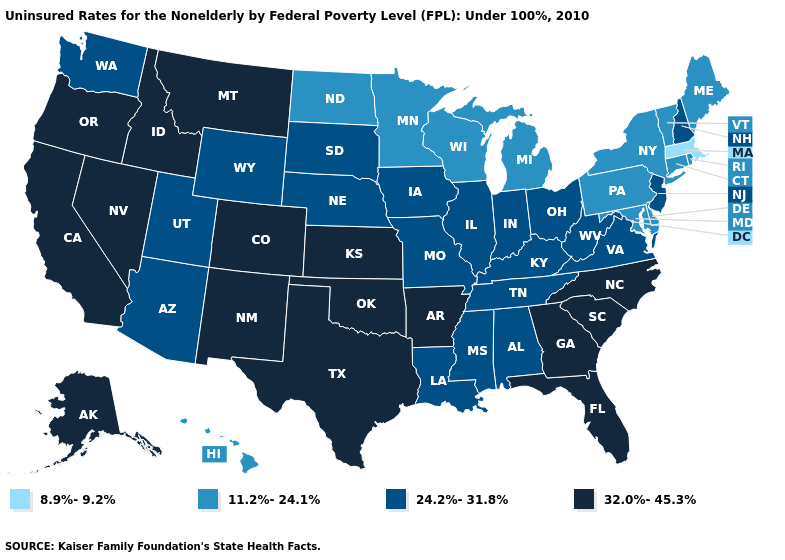What is the highest value in states that border New Hampshire?
Be succinct. 11.2%-24.1%. What is the lowest value in states that border Vermont?
Quick response, please. 8.9%-9.2%. Among the states that border Missouri , does Oklahoma have the highest value?
Quick response, please. Yes. What is the value of New Hampshire?
Be succinct. 24.2%-31.8%. What is the value of South Carolina?
Quick response, please. 32.0%-45.3%. Does Minnesota have a lower value than Rhode Island?
Concise answer only. No. Which states have the highest value in the USA?
Quick response, please. Alaska, Arkansas, California, Colorado, Florida, Georgia, Idaho, Kansas, Montana, Nevada, New Mexico, North Carolina, Oklahoma, Oregon, South Carolina, Texas. How many symbols are there in the legend?
Quick response, please. 4. What is the highest value in states that border South Dakota?
Short answer required. 32.0%-45.3%. Among the states that border Maryland , does Virginia have the lowest value?
Answer briefly. No. Name the states that have a value in the range 8.9%-9.2%?
Write a very short answer. Massachusetts. Does Texas have the same value as California?
Quick response, please. Yes. Does Missouri have a higher value than Vermont?
Concise answer only. Yes. Which states have the lowest value in the USA?
Short answer required. Massachusetts. Is the legend a continuous bar?
Concise answer only. No. 